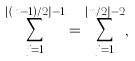<formula> <loc_0><loc_0><loc_500><loc_500>\sum _ { j = 1 } ^ { \lfloor ( n - 1 ) / 2 \rfloor - 1 } = \sum _ { j = 1 } ^ { \lfloor n / 2 \rfloor - 2 } ,</formula> 